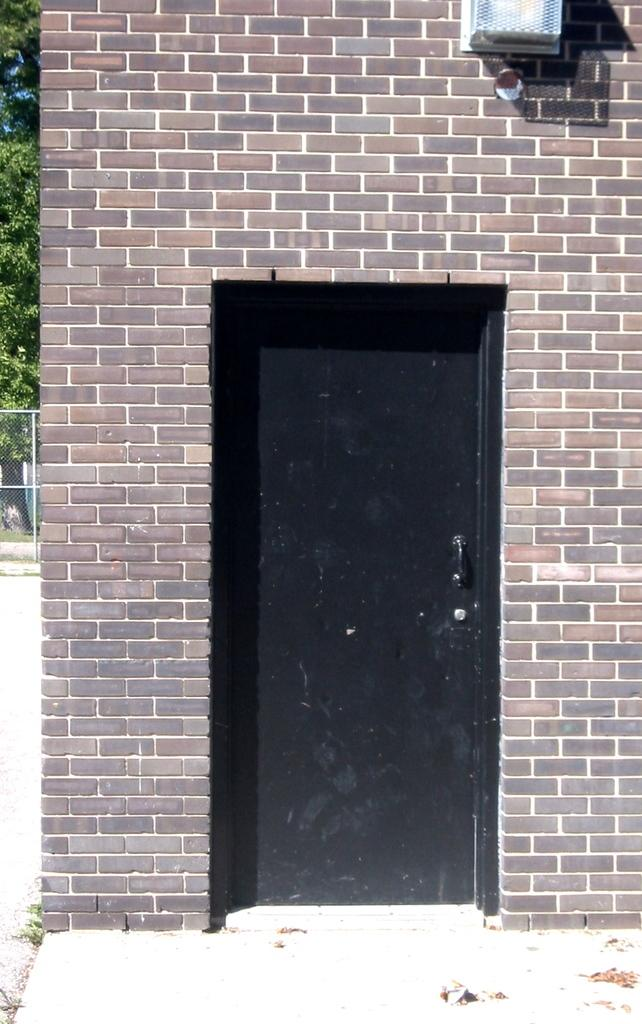What is on the wall in the image? There is an object on the wall in the image. What is a common feature of most rooms or buildings? There is a door in the image. What can be seen in the background of the image? There is a mesh visible in the background of the image, and leaves are also present. What type of skin condition can be seen on the object on the wall in the image? There is no skin condition present on the object on the wall in the image, as it is not a living organism. Is there a servant visible in the image? There is no servant present in the image. What type of musical instrument can be seen in the image? There is no musical instrument present in the image. 